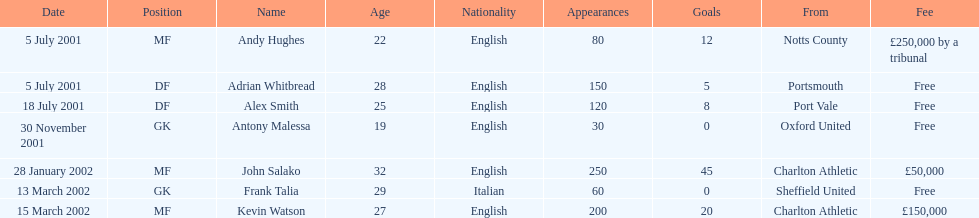Who are all the players? Andy Hughes, Adrian Whitbread, Alex Smith, Antony Malessa, John Salako, Frank Talia, Kevin Watson. What were their fees? £250,000 by a tribunal, Free, Free, Free, £50,000, Free, £150,000. And how much was kevin watson's fee? £150,000. 